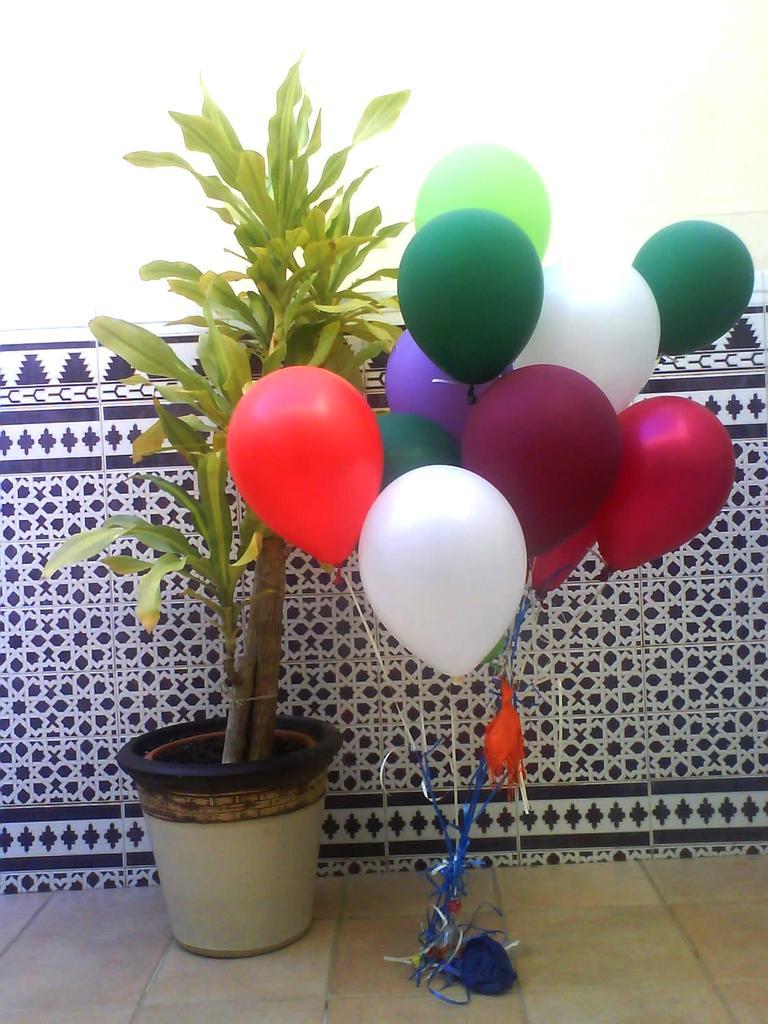Can you describe this image briefly? In the picture I can see a plant which is placed in a plant pot in the left corner and there are few balloons placed beside it and there is a wall which has few designs on it in the background. 